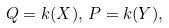<formula> <loc_0><loc_0><loc_500><loc_500>Q = k ( X ) , \, P = k ( Y ) ,</formula> 